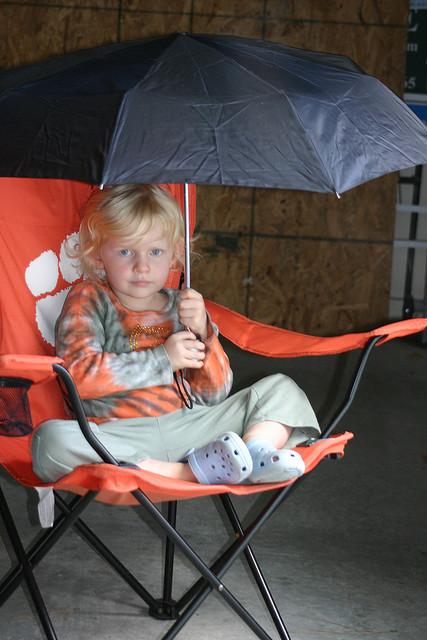How many shoes is the kid wearing?
Quick response, please. 2. Is the child holding the umbrella?
Answer briefly. Yes. What is the kid holding in his hands?
Be succinct. Umbrella. What style shoes does the child wear?
Concise answer only. Crocs. What pattern is on the child's shirt?
Answer briefly. Stripes. 